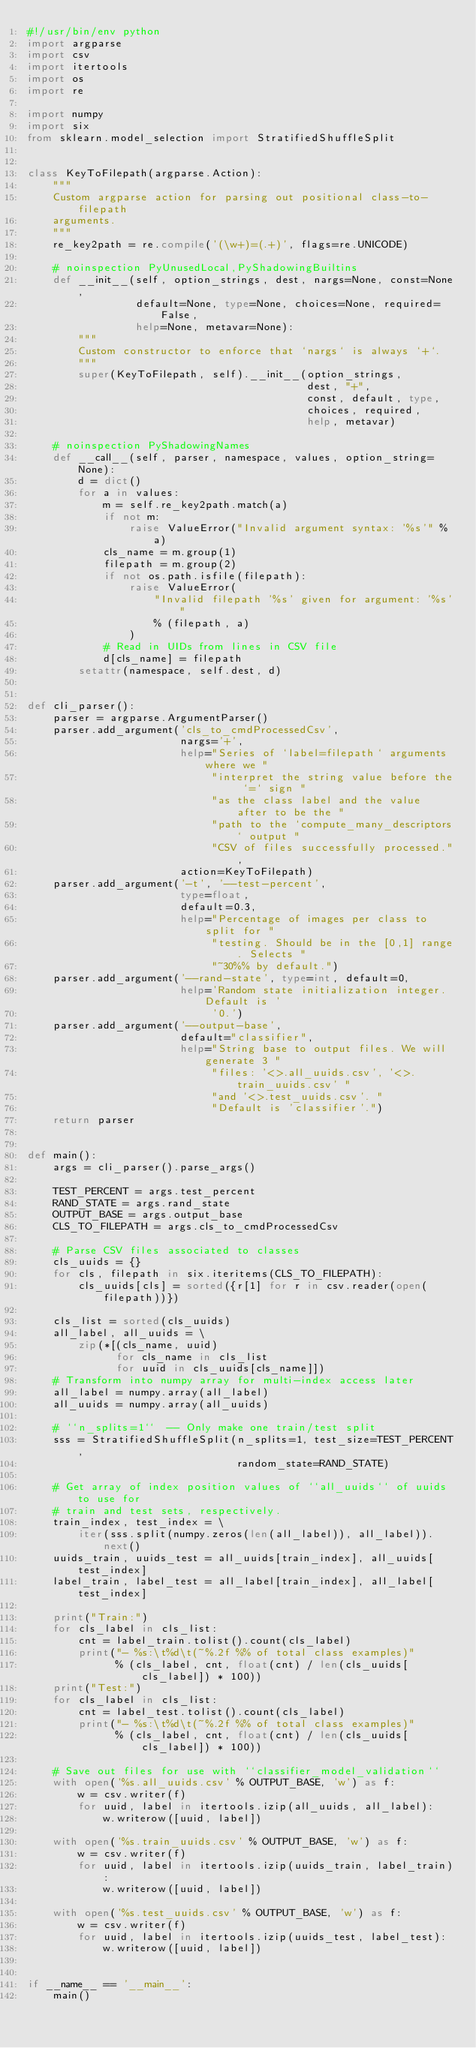<code> <loc_0><loc_0><loc_500><loc_500><_Python_>#!/usr/bin/env python
import argparse
import csv
import itertools
import os
import re

import numpy
import six
from sklearn.model_selection import StratifiedShuffleSplit


class KeyToFilepath(argparse.Action):
    """
    Custom argparse action for parsing out positional class-to-filepath
    arguments.
    """
    re_key2path = re.compile('(\w+)=(.+)', flags=re.UNICODE)

    # noinspection PyUnusedLocal,PyShadowingBuiltins
    def __init__(self, option_strings, dest, nargs=None, const=None,
                 default=None, type=None, choices=None, required=False,
                 help=None, metavar=None):
        """
        Custom constructor to enforce that `nargs` is always `+`.
        """
        super(KeyToFilepath, self).__init__(option_strings,
                                            dest, "+",
                                            const, default, type,
                                            choices, required,
                                            help, metavar)

    # noinspection PyShadowingNames
    def __call__(self, parser, namespace, values, option_string=None):
        d = dict()
        for a in values:
            m = self.re_key2path.match(a)
            if not m:
                raise ValueError("Invalid argument syntax: '%s'" % a)
            cls_name = m.group(1)
            filepath = m.group(2)
            if not os.path.isfile(filepath):
                raise ValueError(
                    "Invalid filepath '%s' given for argument: '%s'"
                    % (filepath, a)
                )
            # Read in UIDs from lines in CSV file
            d[cls_name] = filepath
        setattr(namespace, self.dest, d)


def cli_parser():
    parser = argparse.ArgumentParser()
    parser.add_argument('cls_to_cmdProcessedCsv',
                        nargs='+',
                        help="Series of `label=filepath` arguments where we "
                             "interpret the string value before the `=` sign "
                             "as the class label and the value after to be the "
                             "path to the `compute_many_descriptors` output "
                             "CSV of files successfully processed.",
                        action=KeyToFilepath)
    parser.add_argument('-t', '--test-percent',
                        type=float,
                        default=0.3,
                        help="Percentage of images per class to split for "
                             "testing. Should be in the [0,1] range. Selects "
                             "~30%% by default.")
    parser.add_argument('--rand-state', type=int, default=0,
                        help='Random state initialization integer. Default is '
                             '0.')
    parser.add_argument('--output-base',
                        default="classifier",
                        help="String base to output files. We will generate 3 "
                             "files: '<>.all_uuids.csv', '<>.train_uuids.csv' "
                             "and '<>.test_uuids.csv'. "
                             "Default is 'classifier'.")
    return parser


def main():
    args = cli_parser().parse_args()

    TEST_PERCENT = args.test_percent
    RAND_STATE = args.rand_state
    OUTPUT_BASE = args.output_base
    CLS_TO_FILEPATH = args.cls_to_cmdProcessedCsv

    # Parse CSV files associated to classes
    cls_uuids = {}
    for cls, filepath in six.iteritems(CLS_TO_FILEPATH):
        cls_uuids[cls] = sorted({r[1] for r in csv.reader(open(filepath))})

    cls_list = sorted(cls_uuids)
    all_label, all_uuids = \
        zip(*[(cls_name, uuid)
              for cls_name in cls_list
              for uuid in cls_uuids[cls_name]])
    # Transform into numpy array for multi-index access later
    all_label = numpy.array(all_label)
    all_uuids = numpy.array(all_uuids)

    # ``n_splits=1``  -- Only make one train/test split
    sss = StratifiedShuffleSplit(n_splits=1, test_size=TEST_PERCENT,
                                 random_state=RAND_STATE)

    # Get array of index position values of ``all_uuids`` of uuids to use for
    # train and test sets, respectively.
    train_index, test_index = \
        iter(sss.split(numpy.zeros(len(all_label)), all_label)).next()
    uuids_train, uuids_test = all_uuids[train_index], all_uuids[test_index]
    label_train, label_test = all_label[train_index], all_label[test_index]

    print("Train:")
    for cls_label in cls_list:
        cnt = label_train.tolist().count(cls_label)
        print("- %s:\t%d\t(~%.2f %% of total class examples)"
              % (cls_label, cnt, float(cnt) / len(cls_uuids[cls_label]) * 100))
    print("Test:")
    for cls_label in cls_list:
        cnt = label_test.tolist().count(cls_label)
        print("- %s:\t%d\t(~%.2f %% of total class examples)"
              % (cls_label, cnt, float(cnt) / len(cls_uuids[cls_label]) * 100))

    # Save out files for use with ``classifier_model_validation``
    with open('%s.all_uuids.csv' % OUTPUT_BASE, 'w') as f:
        w = csv.writer(f)
        for uuid, label in itertools.izip(all_uuids, all_label):
            w.writerow([uuid, label])

    with open('%s.train_uuids.csv' % OUTPUT_BASE, 'w') as f:
        w = csv.writer(f)
        for uuid, label in itertools.izip(uuids_train, label_train):
            w.writerow([uuid, label])

    with open('%s.test_uuids.csv' % OUTPUT_BASE, 'w') as f:
        w = csv.writer(f)
        for uuid, label in itertools.izip(uuids_test, label_test):
            w.writerow([uuid, label])


if __name__ == '__main__':
    main()
</code> 